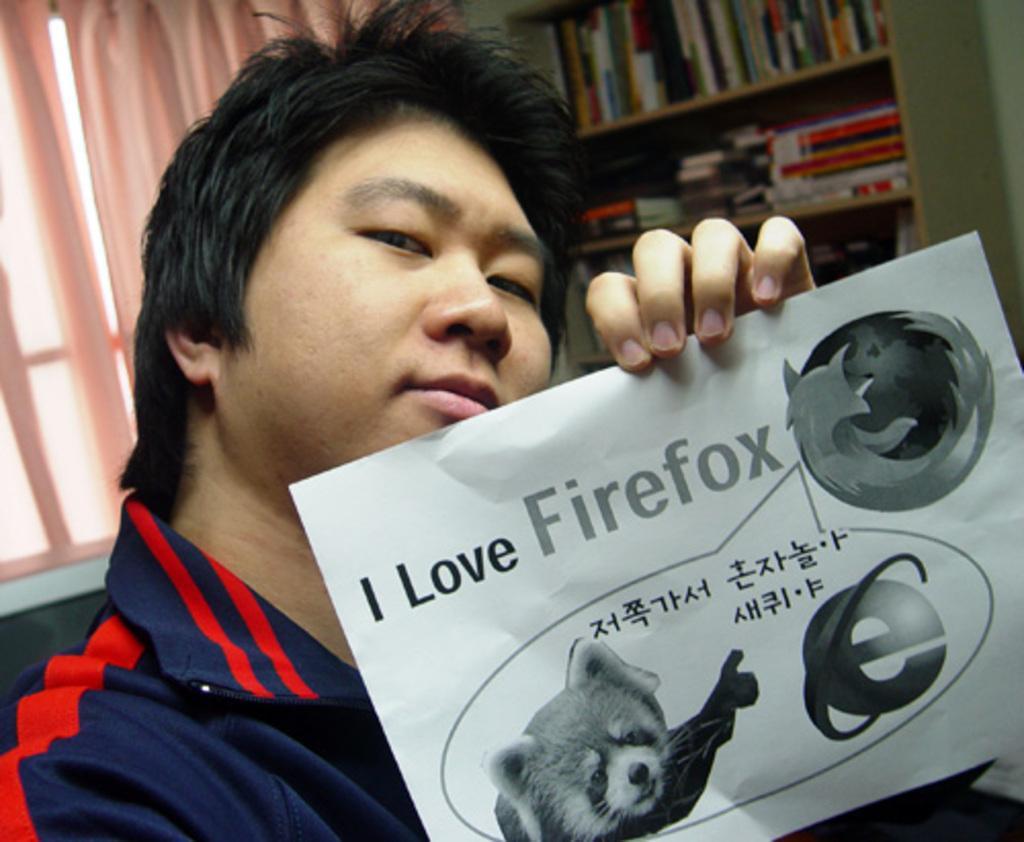In one or two sentences, can you explain what this image depicts? In front of the image there is a person sitting on the chair and he is holding the paper. On the paper there are pictures and there is some text. Behind him there are books on the rack. There are curtains and there is a window. 